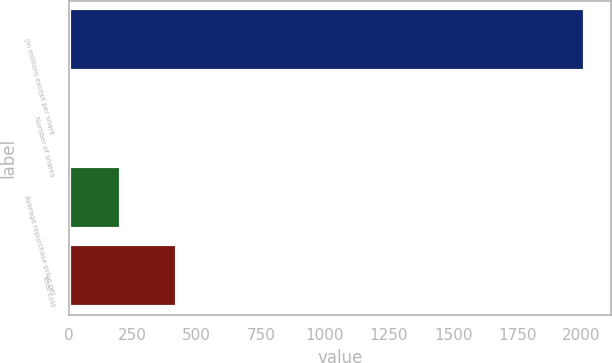Convert chart. <chart><loc_0><loc_0><loc_500><loc_500><bar_chart><fcel>(In millions except per share<fcel>Number of shares<fcel>Average repurchase price per<fcel>Total cost<nl><fcel>2015<fcel>4.8<fcel>205.82<fcel>422<nl></chart> 